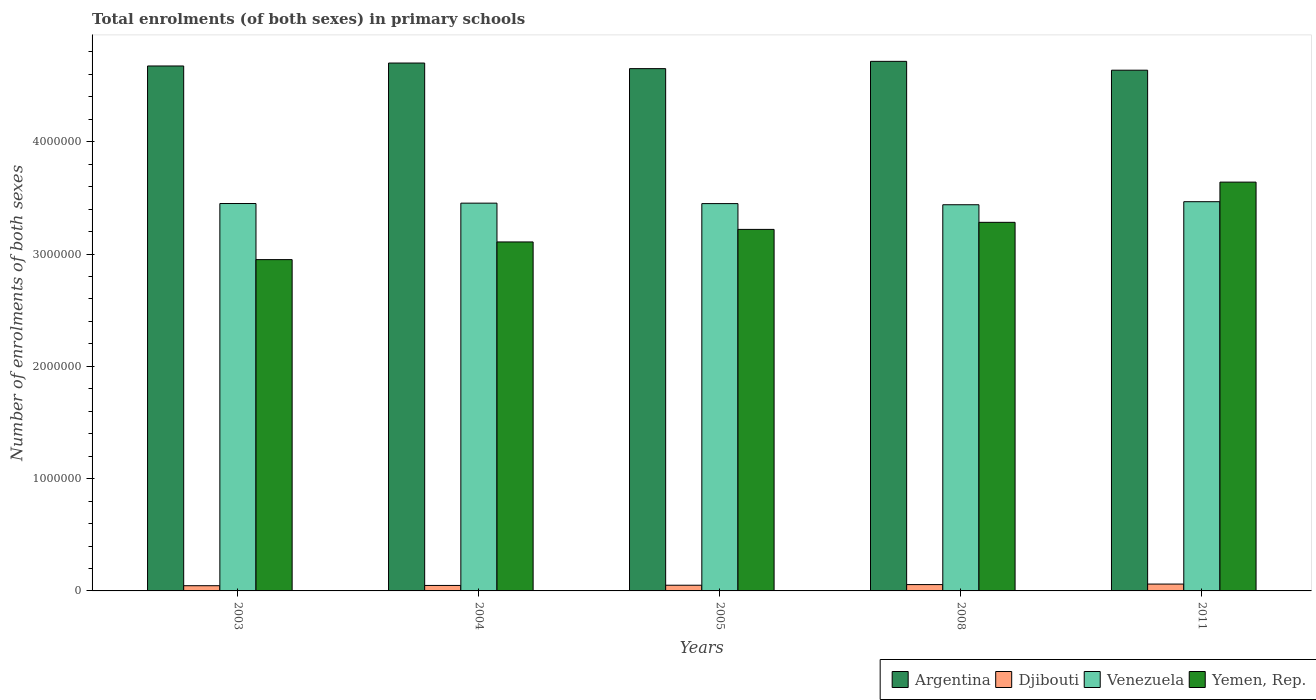How many different coloured bars are there?
Make the answer very short. 4. What is the label of the 4th group of bars from the left?
Give a very brief answer. 2008. What is the number of enrolments in primary schools in Argentina in 2011?
Keep it short and to the point. 4.64e+06. Across all years, what is the maximum number of enrolments in primary schools in Argentina?
Provide a short and direct response. 4.72e+06. Across all years, what is the minimum number of enrolments in primary schools in Yemen, Rep.?
Your answer should be compact. 2.95e+06. What is the total number of enrolments in primary schools in Djibouti in the graph?
Your answer should be very brief. 2.63e+05. What is the difference between the number of enrolments in primary schools in Argentina in 2008 and that in 2011?
Your response must be concise. 7.88e+04. What is the difference between the number of enrolments in primary schools in Djibouti in 2005 and the number of enrolments in primary schools in Argentina in 2003?
Your answer should be very brief. -4.62e+06. What is the average number of enrolments in primary schools in Venezuela per year?
Your answer should be compact. 3.45e+06. In the year 2004, what is the difference between the number of enrolments in primary schools in Venezuela and number of enrolments in primary schools in Yemen, Rep.?
Make the answer very short. 3.46e+05. What is the ratio of the number of enrolments in primary schools in Argentina in 2003 to that in 2008?
Provide a short and direct response. 0.99. Is the number of enrolments in primary schools in Djibouti in 2005 less than that in 2008?
Ensure brevity in your answer.  Yes. Is the difference between the number of enrolments in primary schools in Venezuela in 2003 and 2004 greater than the difference between the number of enrolments in primary schools in Yemen, Rep. in 2003 and 2004?
Your answer should be very brief. Yes. What is the difference between the highest and the second highest number of enrolments in primary schools in Yemen, Rep.?
Your answer should be very brief. 3.58e+05. What is the difference between the highest and the lowest number of enrolments in primary schools in Argentina?
Your response must be concise. 7.88e+04. Is the sum of the number of enrolments in primary schools in Argentina in 2004 and 2011 greater than the maximum number of enrolments in primary schools in Djibouti across all years?
Give a very brief answer. Yes. Is it the case that in every year, the sum of the number of enrolments in primary schools in Argentina and number of enrolments in primary schools in Yemen, Rep. is greater than the sum of number of enrolments in primary schools in Venezuela and number of enrolments in primary schools in Djibouti?
Keep it short and to the point. Yes. What does the 1st bar from the left in 2011 represents?
Ensure brevity in your answer.  Argentina. What does the 3rd bar from the right in 2004 represents?
Ensure brevity in your answer.  Djibouti. How many bars are there?
Provide a succinct answer. 20. What is the difference between two consecutive major ticks on the Y-axis?
Make the answer very short. 1.00e+06. Are the values on the major ticks of Y-axis written in scientific E-notation?
Provide a succinct answer. No. Does the graph contain any zero values?
Ensure brevity in your answer.  No. Does the graph contain grids?
Offer a very short reply. No. Where does the legend appear in the graph?
Keep it short and to the point. Bottom right. How many legend labels are there?
Your response must be concise. 4. How are the legend labels stacked?
Give a very brief answer. Horizontal. What is the title of the graph?
Your answer should be very brief. Total enrolments (of both sexes) in primary schools. What is the label or title of the Y-axis?
Make the answer very short. Number of enrolments of both sexes. What is the Number of enrolments of both sexes in Argentina in 2003?
Provide a succinct answer. 4.67e+06. What is the Number of enrolments of both sexes of Djibouti in 2003?
Offer a very short reply. 4.64e+04. What is the Number of enrolments of both sexes of Venezuela in 2003?
Offer a very short reply. 3.45e+06. What is the Number of enrolments of both sexes in Yemen, Rep. in 2003?
Give a very brief answer. 2.95e+06. What is the Number of enrolments of both sexes of Argentina in 2004?
Your answer should be very brief. 4.70e+06. What is the Number of enrolments of both sexes in Djibouti in 2004?
Offer a terse response. 4.87e+04. What is the Number of enrolments of both sexes of Venezuela in 2004?
Your answer should be compact. 3.45e+06. What is the Number of enrolments of both sexes in Yemen, Rep. in 2004?
Keep it short and to the point. 3.11e+06. What is the Number of enrolments of both sexes in Argentina in 2005?
Ensure brevity in your answer.  4.65e+06. What is the Number of enrolments of both sexes in Djibouti in 2005?
Your response must be concise. 5.07e+04. What is the Number of enrolments of both sexes of Venezuela in 2005?
Offer a terse response. 3.45e+06. What is the Number of enrolments of both sexes in Yemen, Rep. in 2005?
Provide a short and direct response. 3.22e+06. What is the Number of enrolments of both sexes in Argentina in 2008?
Your response must be concise. 4.72e+06. What is the Number of enrolments of both sexes in Djibouti in 2008?
Your answer should be compact. 5.64e+04. What is the Number of enrolments of both sexes of Venezuela in 2008?
Give a very brief answer. 3.44e+06. What is the Number of enrolments of both sexes of Yemen, Rep. in 2008?
Offer a terse response. 3.28e+06. What is the Number of enrolments of both sexes in Argentina in 2011?
Offer a terse response. 4.64e+06. What is the Number of enrolments of both sexes of Djibouti in 2011?
Provide a succinct answer. 6.10e+04. What is the Number of enrolments of both sexes in Venezuela in 2011?
Give a very brief answer. 3.47e+06. What is the Number of enrolments of both sexes in Yemen, Rep. in 2011?
Offer a very short reply. 3.64e+06. Across all years, what is the maximum Number of enrolments of both sexes in Argentina?
Make the answer very short. 4.72e+06. Across all years, what is the maximum Number of enrolments of both sexes in Djibouti?
Your answer should be compact. 6.10e+04. Across all years, what is the maximum Number of enrolments of both sexes in Venezuela?
Your response must be concise. 3.47e+06. Across all years, what is the maximum Number of enrolments of both sexes of Yemen, Rep.?
Your answer should be very brief. 3.64e+06. Across all years, what is the minimum Number of enrolments of both sexes of Argentina?
Your response must be concise. 4.64e+06. Across all years, what is the minimum Number of enrolments of both sexes in Djibouti?
Give a very brief answer. 4.64e+04. Across all years, what is the minimum Number of enrolments of both sexes of Venezuela?
Keep it short and to the point. 3.44e+06. Across all years, what is the minimum Number of enrolments of both sexes of Yemen, Rep.?
Your answer should be compact. 2.95e+06. What is the total Number of enrolments of both sexes of Argentina in the graph?
Provide a short and direct response. 2.34e+07. What is the total Number of enrolments of both sexes of Djibouti in the graph?
Make the answer very short. 2.63e+05. What is the total Number of enrolments of both sexes of Venezuela in the graph?
Ensure brevity in your answer.  1.73e+07. What is the total Number of enrolments of both sexes of Yemen, Rep. in the graph?
Make the answer very short. 1.62e+07. What is the difference between the Number of enrolments of both sexes of Argentina in 2003 and that in 2004?
Ensure brevity in your answer.  -2.63e+04. What is the difference between the Number of enrolments of both sexes in Djibouti in 2003 and that in 2004?
Ensure brevity in your answer.  -2349. What is the difference between the Number of enrolments of both sexes of Venezuela in 2003 and that in 2004?
Make the answer very short. -3395. What is the difference between the Number of enrolments of both sexes in Yemen, Rep. in 2003 and that in 2004?
Keep it short and to the point. -1.57e+05. What is the difference between the Number of enrolments of both sexes of Argentina in 2003 and that in 2005?
Make the answer very short. 2.36e+04. What is the difference between the Number of enrolments of both sexes in Djibouti in 2003 and that in 2005?
Your answer should be very brief. -4287. What is the difference between the Number of enrolments of both sexes of Venezuela in 2003 and that in 2005?
Your response must be concise. 694. What is the difference between the Number of enrolments of both sexes in Yemen, Rep. in 2003 and that in 2005?
Give a very brief answer. -2.69e+05. What is the difference between the Number of enrolments of both sexes in Argentina in 2003 and that in 2008?
Ensure brevity in your answer.  -4.12e+04. What is the difference between the Number of enrolments of both sexes of Djibouti in 2003 and that in 2008?
Give a very brief answer. -1.00e+04. What is the difference between the Number of enrolments of both sexes of Venezuela in 2003 and that in 2008?
Make the answer very short. 1.08e+04. What is the difference between the Number of enrolments of both sexes in Yemen, Rep. in 2003 and that in 2008?
Your answer should be compact. -3.32e+05. What is the difference between the Number of enrolments of both sexes in Argentina in 2003 and that in 2011?
Offer a very short reply. 3.76e+04. What is the difference between the Number of enrolments of both sexes of Djibouti in 2003 and that in 2011?
Offer a terse response. -1.46e+04. What is the difference between the Number of enrolments of both sexes in Venezuela in 2003 and that in 2011?
Ensure brevity in your answer.  -1.62e+04. What is the difference between the Number of enrolments of both sexes of Yemen, Rep. in 2003 and that in 2011?
Ensure brevity in your answer.  -6.90e+05. What is the difference between the Number of enrolments of both sexes of Argentina in 2004 and that in 2005?
Keep it short and to the point. 4.99e+04. What is the difference between the Number of enrolments of both sexes in Djibouti in 2004 and that in 2005?
Offer a very short reply. -1938. What is the difference between the Number of enrolments of both sexes in Venezuela in 2004 and that in 2005?
Offer a very short reply. 4089. What is the difference between the Number of enrolments of both sexes of Yemen, Rep. in 2004 and that in 2005?
Ensure brevity in your answer.  -1.12e+05. What is the difference between the Number of enrolments of both sexes of Argentina in 2004 and that in 2008?
Provide a short and direct response. -1.50e+04. What is the difference between the Number of enrolments of both sexes in Djibouti in 2004 and that in 2008?
Keep it short and to the point. -7682. What is the difference between the Number of enrolments of both sexes of Venezuela in 2004 and that in 2008?
Provide a short and direct response. 1.42e+04. What is the difference between the Number of enrolments of both sexes in Yemen, Rep. in 2004 and that in 2008?
Offer a very short reply. -1.75e+05. What is the difference between the Number of enrolments of both sexes of Argentina in 2004 and that in 2011?
Provide a short and direct response. 6.39e+04. What is the difference between the Number of enrolments of both sexes in Djibouti in 2004 and that in 2011?
Give a very brief answer. -1.23e+04. What is the difference between the Number of enrolments of both sexes in Venezuela in 2004 and that in 2011?
Provide a succinct answer. -1.29e+04. What is the difference between the Number of enrolments of both sexes in Yemen, Rep. in 2004 and that in 2011?
Keep it short and to the point. -5.33e+05. What is the difference between the Number of enrolments of both sexes of Argentina in 2005 and that in 2008?
Provide a short and direct response. -6.48e+04. What is the difference between the Number of enrolments of both sexes in Djibouti in 2005 and that in 2008?
Keep it short and to the point. -5744. What is the difference between the Number of enrolments of both sexes in Venezuela in 2005 and that in 2008?
Your response must be concise. 1.01e+04. What is the difference between the Number of enrolments of both sexes in Yemen, Rep. in 2005 and that in 2008?
Your answer should be compact. -6.29e+04. What is the difference between the Number of enrolments of both sexes of Argentina in 2005 and that in 2011?
Your answer should be compact. 1.40e+04. What is the difference between the Number of enrolments of both sexes in Djibouti in 2005 and that in 2011?
Your answer should be compact. -1.03e+04. What is the difference between the Number of enrolments of both sexes of Venezuela in 2005 and that in 2011?
Your response must be concise. -1.69e+04. What is the difference between the Number of enrolments of both sexes of Yemen, Rep. in 2005 and that in 2011?
Provide a short and direct response. -4.21e+05. What is the difference between the Number of enrolments of both sexes in Argentina in 2008 and that in 2011?
Offer a terse response. 7.88e+04. What is the difference between the Number of enrolments of both sexes of Djibouti in 2008 and that in 2011?
Your answer should be compact. -4597. What is the difference between the Number of enrolments of both sexes of Venezuela in 2008 and that in 2011?
Provide a succinct answer. -2.70e+04. What is the difference between the Number of enrolments of both sexes in Yemen, Rep. in 2008 and that in 2011?
Provide a short and direct response. -3.58e+05. What is the difference between the Number of enrolments of both sexes in Argentina in 2003 and the Number of enrolments of both sexes in Djibouti in 2004?
Your response must be concise. 4.63e+06. What is the difference between the Number of enrolments of both sexes in Argentina in 2003 and the Number of enrolments of both sexes in Venezuela in 2004?
Your answer should be compact. 1.22e+06. What is the difference between the Number of enrolments of both sexes of Argentina in 2003 and the Number of enrolments of both sexes of Yemen, Rep. in 2004?
Keep it short and to the point. 1.57e+06. What is the difference between the Number of enrolments of both sexes of Djibouti in 2003 and the Number of enrolments of both sexes of Venezuela in 2004?
Your answer should be very brief. -3.41e+06. What is the difference between the Number of enrolments of both sexes in Djibouti in 2003 and the Number of enrolments of both sexes in Yemen, Rep. in 2004?
Your answer should be compact. -3.06e+06. What is the difference between the Number of enrolments of both sexes of Venezuela in 2003 and the Number of enrolments of both sexes of Yemen, Rep. in 2004?
Your answer should be very brief. 3.42e+05. What is the difference between the Number of enrolments of both sexes in Argentina in 2003 and the Number of enrolments of both sexes in Djibouti in 2005?
Your response must be concise. 4.62e+06. What is the difference between the Number of enrolments of both sexes in Argentina in 2003 and the Number of enrolments of both sexes in Venezuela in 2005?
Offer a terse response. 1.23e+06. What is the difference between the Number of enrolments of both sexes of Argentina in 2003 and the Number of enrolments of both sexes of Yemen, Rep. in 2005?
Make the answer very short. 1.46e+06. What is the difference between the Number of enrolments of both sexes of Djibouti in 2003 and the Number of enrolments of both sexes of Venezuela in 2005?
Your answer should be very brief. -3.40e+06. What is the difference between the Number of enrolments of both sexes of Djibouti in 2003 and the Number of enrolments of both sexes of Yemen, Rep. in 2005?
Offer a terse response. -3.17e+06. What is the difference between the Number of enrolments of both sexes in Venezuela in 2003 and the Number of enrolments of both sexes in Yemen, Rep. in 2005?
Offer a terse response. 2.30e+05. What is the difference between the Number of enrolments of both sexes in Argentina in 2003 and the Number of enrolments of both sexes in Djibouti in 2008?
Offer a terse response. 4.62e+06. What is the difference between the Number of enrolments of both sexes in Argentina in 2003 and the Number of enrolments of both sexes in Venezuela in 2008?
Provide a short and direct response. 1.24e+06. What is the difference between the Number of enrolments of both sexes in Argentina in 2003 and the Number of enrolments of both sexes in Yemen, Rep. in 2008?
Keep it short and to the point. 1.39e+06. What is the difference between the Number of enrolments of both sexes in Djibouti in 2003 and the Number of enrolments of both sexes in Venezuela in 2008?
Offer a very short reply. -3.39e+06. What is the difference between the Number of enrolments of both sexes of Djibouti in 2003 and the Number of enrolments of both sexes of Yemen, Rep. in 2008?
Give a very brief answer. -3.24e+06. What is the difference between the Number of enrolments of both sexes in Venezuela in 2003 and the Number of enrolments of both sexes in Yemen, Rep. in 2008?
Give a very brief answer. 1.68e+05. What is the difference between the Number of enrolments of both sexes in Argentina in 2003 and the Number of enrolments of both sexes in Djibouti in 2011?
Keep it short and to the point. 4.61e+06. What is the difference between the Number of enrolments of both sexes of Argentina in 2003 and the Number of enrolments of both sexes of Venezuela in 2011?
Offer a terse response. 1.21e+06. What is the difference between the Number of enrolments of both sexes in Argentina in 2003 and the Number of enrolments of both sexes in Yemen, Rep. in 2011?
Ensure brevity in your answer.  1.03e+06. What is the difference between the Number of enrolments of both sexes in Djibouti in 2003 and the Number of enrolments of both sexes in Venezuela in 2011?
Give a very brief answer. -3.42e+06. What is the difference between the Number of enrolments of both sexes of Djibouti in 2003 and the Number of enrolments of both sexes of Yemen, Rep. in 2011?
Give a very brief answer. -3.59e+06. What is the difference between the Number of enrolments of both sexes in Venezuela in 2003 and the Number of enrolments of both sexes in Yemen, Rep. in 2011?
Make the answer very short. -1.91e+05. What is the difference between the Number of enrolments of both sexes of Argentina in 2004 and the Number of enrolments of both sexes of Djibouti in 2005?
Make the answer very short. 4.65e+06. What is the difference between the Number of enrolments of both sexes of Argentina in 2004 and the Number of enrolments of both sexes of Venezuela in 2005?
Your response must be concise. 1.25e+06. What is the difference between the Number of enrolments of both sexes in Argentina in 2004 and the Number of enrolments of both sexes in Yemen, Rep. in 2005?
Your answer should be compact. 1.48e+06. What is the difference between the Number of enrolments of both sexes of Djibouti in 2004 and the Number of enrolments of both sexes of Venezuela in 2005?
Keep it short and to the point. -3.40e+06. What is the difference between the Number of enrolments of both sexes of Djibouti in 2004 and the Number of enrolments of both sexes of Yemen, Rep. in 2005?
Provide a short and direct response. -3.17e+06. What is the difference between the Number of enrolments of both sexes of Venezuela in 2004 and the Number of enrolments of both sexes of Yemen, Rep. in 2005?
Your answer should be compact. 2.34e+05. What is the difference between the Number of enrolments of both sexes in Argentina in 2004 and the Number of enrolments of both sexes in Djibouti in 2008?
Keep it short and to the point. 4.64e+06. What is the difference between the Number of enrolments of both sexes in Argentina in 2004 and the Number of enrolments of both sexes in Venezuela in 2008?
Your response must be concise. 1.26e+06. What is the difference between the Number of enrolments of both sexes in Argentina in 2004 and the Number of enrolments of both sexes in Yemen, Rep. in 2008?
Provide a short and direct response. 1.42e+06. What is the difference between the Number of enrolments of both sexes of Djibouti in 2004 and the Number of enrolments of both sexes of Venezuela in 2008?
Your response must be concise. -3.39e+06. What is the difference between the Number of enrolments of both sexes in Djibouti in 2004 and the Number of enrolments of both sexes in Yemen, Rep. in 2008?
Give a very brief answer. -3.23e+06. What is the difference between the Number of enrolments of both sexes in Venezuela in 2004 and the Number of enrolments of both sexes in Yemen, Rep. in 2008?
Make the answer very short. 1.71e+05. What is the difference between the Number of enrolments of both sexes in Argentina in 2004 and the Number of enrolments of both sexes in Djibouti in 2011?
Your answer should be compact. 4.64e+06. What is the difference between the Number of enrolments of both sexes in Argentina in 2004 and the Number of enrolments of both sexes in Venezuela in 2011?
Offer a terse response. 1.23e+06. What is the difference between the Number of enrolments of both sexes in Argentina in 2004 and the Number of enrolments of both sexes in Yemen, Rep. in 2011?
Offer a terse response. 1.06e+06. What is the difference between the Number of enrolments of both sexes of Djibouti in 2004 and the Number of enrolments of both sexes of Venezuela in 2011?
Your answer should be compact. -3.42e+06. What is the difference between the Number of enrolments of both sexes of Djibouti in 2004 and the Number of enrolments of both sexes of Yemen, Rep. in 2011?
Provide a succinct answer. -3.59e+06. What is the difference between the Number of enrolments of both sexes in Venezuela in 2004 and the Number of enrolments of both sexes in Yemen, Rep. in 2011?
Offer a terse response. -1.87e+05. What is the difference between the Number of enrolments of both sexes of Argentina in 2005 and the Number of enrolments of both sexes of Djibouti in 2008?
Offer a very short reply. 4.59e+06. What is the difference between the Number of enrolments of both sexes of Argentina in 2005 and the Number of enrolments of both sexes of Venezuela in 2008?
Your answer should be very brief. 1.21e+06. What is the difference between the Number of enrolments of both sexes of Argentina in 2005 and the Number of enrolments of both sexes of Yemen, Rep. in 2008?
Give a very brief answer. 1.37e+06. What is the difference between the Number of enrolments of both sexes of Djibouti in 2005 and the Number of enrolments of both sexes of Venezuela in 2008?
Provide a short and direct response. -3.39e+06. What is the difference between the Number of enrolments of both sexes in Djibouti in 2005 and the Number of enrolments of both sexes in Yemen, Rep. in 2008?
Ensure brevity in your answer.  -3.23e+06. What is the difference between the Number of enrolments of both sexes of Venezuela in 2005 and the Number of enrolments of both sexes of Yemen, Rep. in 2008?
Give a very brief answer. 1.67e+05. What is the difference between the Number of enrolments of both sexes of Argentina in 2005 and the Number of enrolments of both sexes of Djibouti in 2011?
Provide a succinct answer. 4.59e+06. What is the difference between the Number of enrolments of both sexes of Argentina in 2005 and the Number of enrolments of both sexes of Venezuela in 2011?
Ensure brevity in your answer.  1.19e+06. What is the difference between the Number of enrolments of both sexes of Argentina in 2005 and the Number of enrolments of both sexes of Yemen, Rep. in 2011?
Make the answer very short. 1.01e+06. What is the difference between the Number of enrolments of both sexes in Djibouti in 2005 and the Number of enrolments of both sexes in Venezuela in 2011?
Offer a very short reply. -3.42e+06. What is the difference between the Number of enrolments of both sexes in Djibouti in 2005 and the Number of enrolments of both sexes in Yemen, Rep. in 2011?
Your answer should be compact. -3.59e+06. What is the difference between the Number of enrolments of both sexes in Venezuela in 2005 and the Number of enrolments of both sexes in Yemen, Rep. in 2011?
Make the answer very short. -1.91e+05. What is the difference between the Number of enrolments of both sexes of Argentina in 2008 and the Number of enrolments of both sexes of Djibouti in 2011?
Offer a very short reply. 4.66e+06. What is the difference between the Number of enrolments of both sexes of Argentina in 2008 and the Number of enrolments of both sexes of Venezuela in 2011?
Offer a terse response. 1.25e+06. What is the difference between the Number of enrolments of both sexes in Argentina in 2008 and the Number of enrolments of both sexes in Yemen, Rep. in 2011?
Ensure brevity in your answer.  1.08e+06. What is the difference between the Number of enrolments of both sexes of Djibouti in 2008 and the Number of enrolments of both sexes of Venezuela in 2011?
Your response must be concise. -3.41e+06. What is the difference between the Number of enrolments of both sexes of Djibouti in 2008 and the Number of enrolments of both sexes of Yemen, Rep. in 2011?
Your response must be concise. -3.58e+06. What is the difference between the Number of enrolments of both sexes in Venezuela in 2008 and the Number of enrolments of both sexes in Yemen, Rep. in 2011?
Your response must be concise. -2.01e+05. What is the average Number of enrolments of both sexes in Argentina per year?
Offer a very short reply. 4.68e+06. What is the average Number of enrolments of both sexes of Djibouti per year?
Provide a short and direct response. 5.26e+04. What is the average Number of enrolments of both sexes in Venezuela per year?
Your answer should be compact. 3.45e+06. What is the average Number of enrolments of both sexes in Yemen, Rep. per year?
Keep it short and to the point. 3.24e+06. In the year 2003, what is the difference between the Number of enrolments of both sexes of Argentina and Number of enrolments of both sexes of Djibouti?
Give a very brief answer. 4.63e+06. In the year 2003, what is the difference between the Number of enrolments of both sexes of Argentina and Number of enrolments of both sexes of Venezuela?
Give a very brief answer. 1.22e+06. In the year 2003, what is the difference between the Number of enrolments of both sexes of Argentina and Number of enrolments of both sexes of Yemen, Rep.?
Provide a succinct answer. 1.72e+06. In the year 2003, what is the difference between the Number of enrolments of both sexes in Djibouti and Number of enrolments of both sexes in Venezuela?
Make the answer very short. -3.40e+06. In the year 2003, what is the difference between the Number of enrolments of both sexes of Djibouti and Number of enrolments of both sexes of Yemen, Rep.?
Ensure brevity in your answer.  -2.90e+06. In the year 2003, what is the difference between the Number of enrolments of both sexes of Venezuela and Number of enrolments of both sexes of Yemen, Rep.?
Ensure brevity in your answer.  5.00e+05. In the year 2004, what is the difference between the Number of enrolments of both sexes in Argentina and Number of enrolments of both sexes in Djibouti?
Provide a short and direct response. 4.65e+06. In the year 2004, what is the difference between the Number of enrolments of both sexes in Argentina and Number of enrolments of both sexes in Venezuela?
Your response must be concise. 1.25e+06. In the year 2004, what is the difference between the Number of enrolments of both sexes of Argentina and Number of enrolments of both sexes of Yemen, Rep.?
Provide a succinct answer. 1.59e+06. In the year 2004, what is the difference between the Number of enrolments of both sexes in Djibouti and Number of enrolments of both sexes in Venezuela?
Make the answer very short. -3.40e+06. In the year 2004, what is the difference between the Number of enrolments of both sexes in Djibouti and Number of enrolments of both sexes in Yemen, Rep.?
Your response must be concise. -3.06e+06. In the year 2004, what is the difference between the Number of enrolments of both sexes in Venezuela and Number of enrolments of both sexes in Yemen, Rep.?
Provide a short and direct response. 3.46e+05. In the year 2005, what is the difference between the Number of enrolments of both sexes in Argentina and Number of enrolments of both sexes in Djibouti?
Your response must be concise. 4.60e+06. In the year 2005, what is the difference between the Number of enrolments of both sexes in Argentina and Number of enrolments of both sexes in Venezuela?
Your response must be concise. 1.20e+06. In the year 2005, what is the difference between the Number of enrolments of both sexes of Argentina and Number of enrolments of both sexes of Yemen, Rep.?
Your answer should be compact. 1.43e+06. In the year 2005, what is the difference between the Number of enrolments of both sexes of Djibouti and Number of enrolments of both sexes of Venezuela?
Offer a very short reply. -3.40e+06. In the year 2005, what is the difference between the Number of enrolments of both sexes in Djibouti and Number of enrolments of both sexes in Yemen, Rep.?
Offer a very short reply. -3.17e+06. In the year 2005, what is the difference between the Number of enrolments of both sexes of Venezuela and Number of enrolments of both sexes of Yemen, Rep.?
Offer a very short reply. 2.30e+05. In the year 2008, what is the difference between the Number of enrolments of both sexes of Argentina and Number of enrolments of both sexes of Djibouti?
Your answer should be very brief. 4.66e+06. In the year 2008, what is the difference between the Number of enrolments of both sexes of Argentina and Number of enrolments of both sexes of Venezuela?
Ensure brevity in your answer.  1.28e+06. In the year 2008, what is the difference between the Number of enrolments of both sexes of Argentina and Number of enrolments of both sexes of Yemen, Rep.?
Keep it short and to the point. 1.43e+06. In the year 2008, what is the difference between the Number of enrolments of both sexes in Djibouti and Number of enrolments of both sexes in Venezuela?
Offer a very short reply. -3.38e+06. In the year 2008, what is the difference between the Number of enrolments of both sexes in Djibouti and Number of enrolments of both sexes in Yemen, Rep.?
Offer a terse response. -3.23e+06. In the year 2008, what is the difference between the Number of enrolments of both sexes of Venezuela and Number of enrolments of both sexes of Yemen, Rep.?
Ensure brevity in your answer.  1.57e+05. In the year 2011, what is the difference between the Number of enrolments of both sexes of Argentina and Number of enrolments of both sexes of Djibouti?
Ensure brevity in your answer.  4.58e+06. In the year 2011, what is the difference between the Number of enrolments of both sexes of Argentina and Number of enrolments of both sexes of Venezuela?
Provide a short and direct response. 1.17e+06. In the year 2011, what is the difference between the Number of enrolments of both sexes in Argentina and Number of enrolments of both sexes in Yemen, Rep.?
Keep it short and to the point. 9.97e+05. In the year 2011, what is the difference between the Number of enrolments of both sexes of Djibouti and Number of enrolments of both sexes of Venezuela?
Your answer should be compact. -3.41e+06. In the year 2011, what is the difference between the Number of enrolments of both sexes in Djibouti and Number of enrolments of both sexes in Yemen, Rep.?
Keep it short and to the point. -3.58e+06. In the year 2011, what is the difference between the Number of enrolments of both sexes in Venezuela and Number of enrolments of both sexes in Yemen, Rep.?
Offer a very short reply. -1.74e+05. What is the ratio of the Number of enrolments of both sexes in Djibouti in 2003 to that in 2004?
Offer a very short reply. 0.95. What is the ratio of the Number of enrolments of both sexes of Yemen, Rep. in 2003 to that in 2004?
Provide a short and direct response. 0.95. What is the ratio of the Number of enrolments of both sexes of Djibouti in 2003 to that in 2005?
Give a very brief answer. 0.92. What is the ratio of the Number of enrolments of both sexes in Venezuela in 2003 to that in 2005?
Your answer should be compact. 1. What is the ratio of the Number of enrolments of both sexes of Yemen, Rep. in 2003 to that in 2005?
Provide a short and direct response. 0.92. What is the ratio of the Number of enrolments of both sexes of Djibouti in 2003 to that in 2008?
Provide a short and direct response. 0.82. What is the ratio of the Number of enrolments of both sexes in Venezuela in 2003 to that in 2008?
Provide a short and direct response. 1. What is the ratio of the Number of enrolments of both sexes in Yemen, Rep. in 2003 to that in 2008?
Provide a short and direct response. 0.9. What is the ratio of the Number of enrolments of both sexes of Djibouti in 2003 to that in 2011?
Ensure brevity in your answer.  0.76. What is the ratio of the Number of enrolments of both sexes of Venezuela in 2003 to that in 2011?
Ensure brevity in your answer.  1. What is the ratio of the Number of enrolments of both sexes in Yemen, Rep. in 2003 to that in 2011?
Keep it short and to the point. 0.81. What is the ratio of the Number of enrolments of both sexes of Argentina in 2004 to that in 2005?
Provide a short and direct response. 1.01. What is the ratio of the Number of enrolments of both sexes of Djibouti in 2004 to that in 2005?
Make the answer very short. 0.96. What is the ratio of the Number of enrolments of both sexes in Yemen, Rep. in 2004 to that in 2005?
Make the answer very short. 0.97. What is the ratio of the Number of enrolments of both sexes of Argentina in 2004 to that in 2008?
Make the answer very short. 1. What is the ratio of the Number of enrolments of both sexes of Djibouti in 2004 to that in 2008?
Your answer should be compact. 0.86. What is the ratio of the Number of enrolments of both sexes in Venezuela in 2004 to that in 2008?
Your answer should be very brief. 1. What is the ratio of the Number of enrolments of both sexes of Yemen, Rep. in 2004 to that in 2008?
Your response must be concise. 0.95. What is the ratio of the Number of enrolments of both sexes of Argentina in 2004 to that in 2011?
Ensure brevity in your answer.  1.01. What is the ratio of the Number of enrolments of both sexes in Djibouti in 2004 to that in 2011?
Your answer should be compact. 0.8. What is the ratio of the Number of enrolments of both sexes in Yemen, Rep. in 2004 to that in 2011?
Give a very brief answer. 0.85. What is the ratio of the Number of enrolments of both sexes of Argentina in 2005 to that in 2008?
Your answer should be very brief. 0.99. What is the ratio of the Number of enrolments of both sexes in Djibouti in 2005 to that in 2008?
Give a very brief answer. 0.9. What is the ratio of the Number of enrolments of both sexes of Yemen, Rep. in 2005 to that in 2008?
Provide a succinct answer. 0.98. What is the ratio of the Number of enrolments of both sexes of Argentina in 2005 to that in 2011?
Your response must be concise. 1. What is the ratio of the Number of enrolments of both sexes in Djibouti in 2005 to that in 2011?
Offer a very short reply. 0.83. What is the ratio of the Number of enrolments of both sexes of Venezuela in 2005 to that in 2011?
Provide a succinct answer. 1. What is the ratio of the Number of enrolments of both sexes of Yemen, Rep. in 2005 to that in 2011?
Offer a very short reply. 0.88. What is the ratio of the Number of enrolments of both sexes of Djibouti in 2008 to that in 2011?
Make the answer very short. 0.92. What is the ratio of the Number of enrolments of both sexes of Yemen, Rep. in 2008 to that in 2011?
Offer a very short reply. 0.9. What is the difference between the highest and the second highest Number of enrolments of both sexes of Argentina?
Ensure brevity in your answer.  1.50e+04. What is the difference between the highest and the second highest Number of enrolments of both sexes of Djibouti?
Provide a short and direct response. 4597. What is the difference between the highest and the second highest Number of enrolments of both sexes in Venezuela?
Ensure brevity in your answer.  1.29e+04. What is the difference between the highest and the second highest Number of enrolments of both sexes in Yemen, Rep.?
Provide a short and direct response. 3.58e+05. What is the difference between the highest and the lowest Number of enrolments of both sexes in Argentina?
Your answer should be very brief. 7.88e+04. What is the difference between the highest and the lowest Number of enrolments of both sexes of Djibouti?
Provide a succinct answer. 1.46e+04. What is the difference between the highest and the lowest Number of enrolments of both sexes of Venezuela?
Give a very brief answer. 2.70e+04. What is the difference between the highest and the lowest Number of enrolments of both sexes of Yemen, Rep.?
Provide a succinct answer. 6.90e+05. 